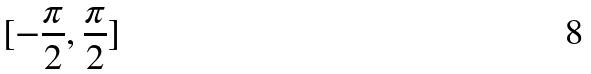Convert formula to latex. <formula><loc_0><loc_0><loc_500><loc_500>[ - \frac { \pi } { 2 } , \frac { \pi } { 2 } ]</formula> 